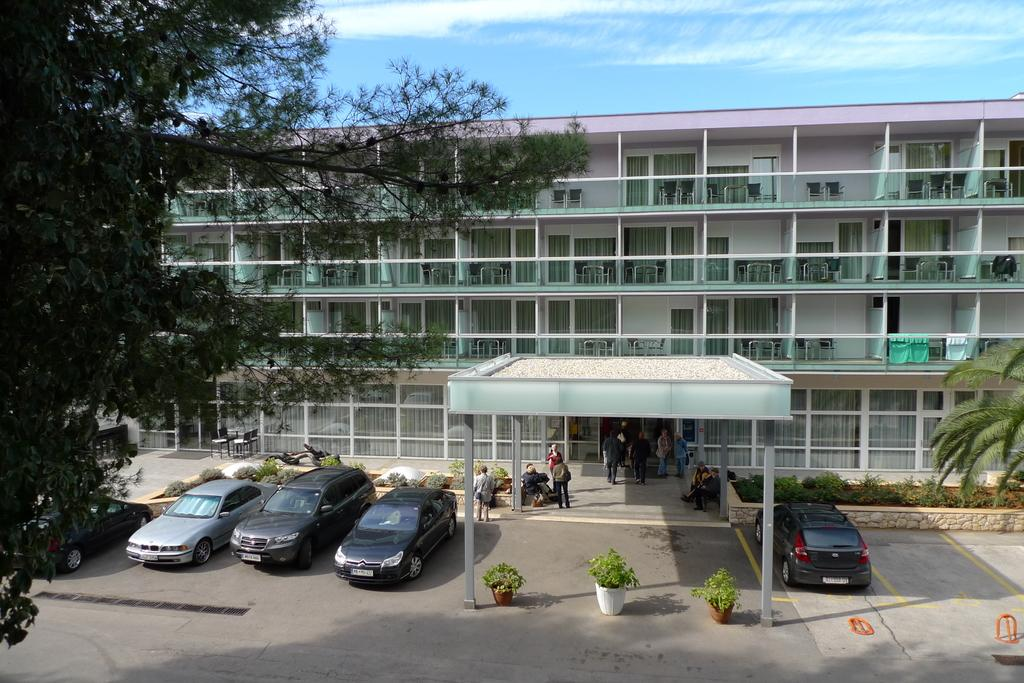What is located at the bottom of the image? There is a road at the bottom of the image. What can be seen on the road? Cars are present on the road. What are the people near the road doing? There are people standing near the road. What is visible in the background of the image? There is a building in the background of the image. What is visible at the top of the image? The sky is visible at the top of the image. Where is the map located in the image? There is no map present in the image. Can you tell me how many cacti are visible in the image? There are no cacti present in the image. 